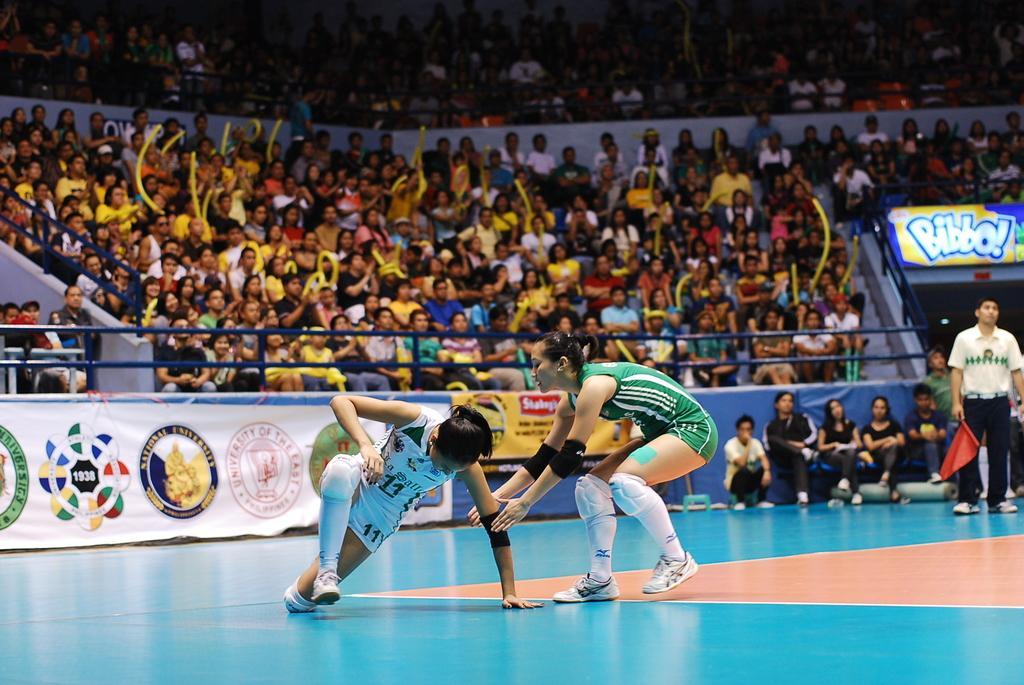Describe this image in one or two sentences. In this picture, it looks like a stadium and in the stadium a woman is walking and another woman is in squat position. Behind the women there are groups of people sitting and holding some objects, and a person is standing. Behind the two women there are boards and iron grilles. 